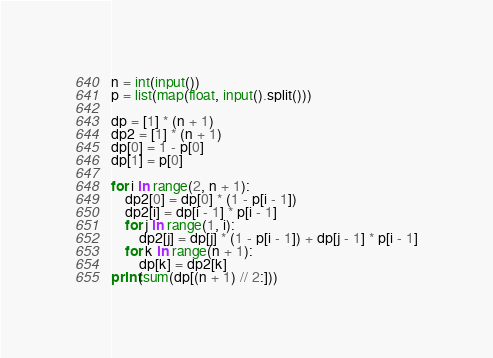<code> <loc_0><loc_0><loc_500><loc_500><_Cython_>n = int(input())
p = list(map(float, input().split()))

dp = [1] * (n + 1)
dp2 = [1] * (n + 1)
dp[0] = 1 - p[0]
dp[1] = p[0]

for i in range(2, n + 1):
    dp2[0] = dp[0] * (1 - p[i - 1])
    dp2[i] = dp[i - 1] * p[i - 1]
    for j in range(1, i):
        dp2[j] = dp[j] * (1 - p[i - 1]) + dp[j - 1] * p[i - 1]
    for k in range(n + 1):
        dp[k] = dp2[k]
print(sum(dp[(n + 1) // 2:]))
</code> 